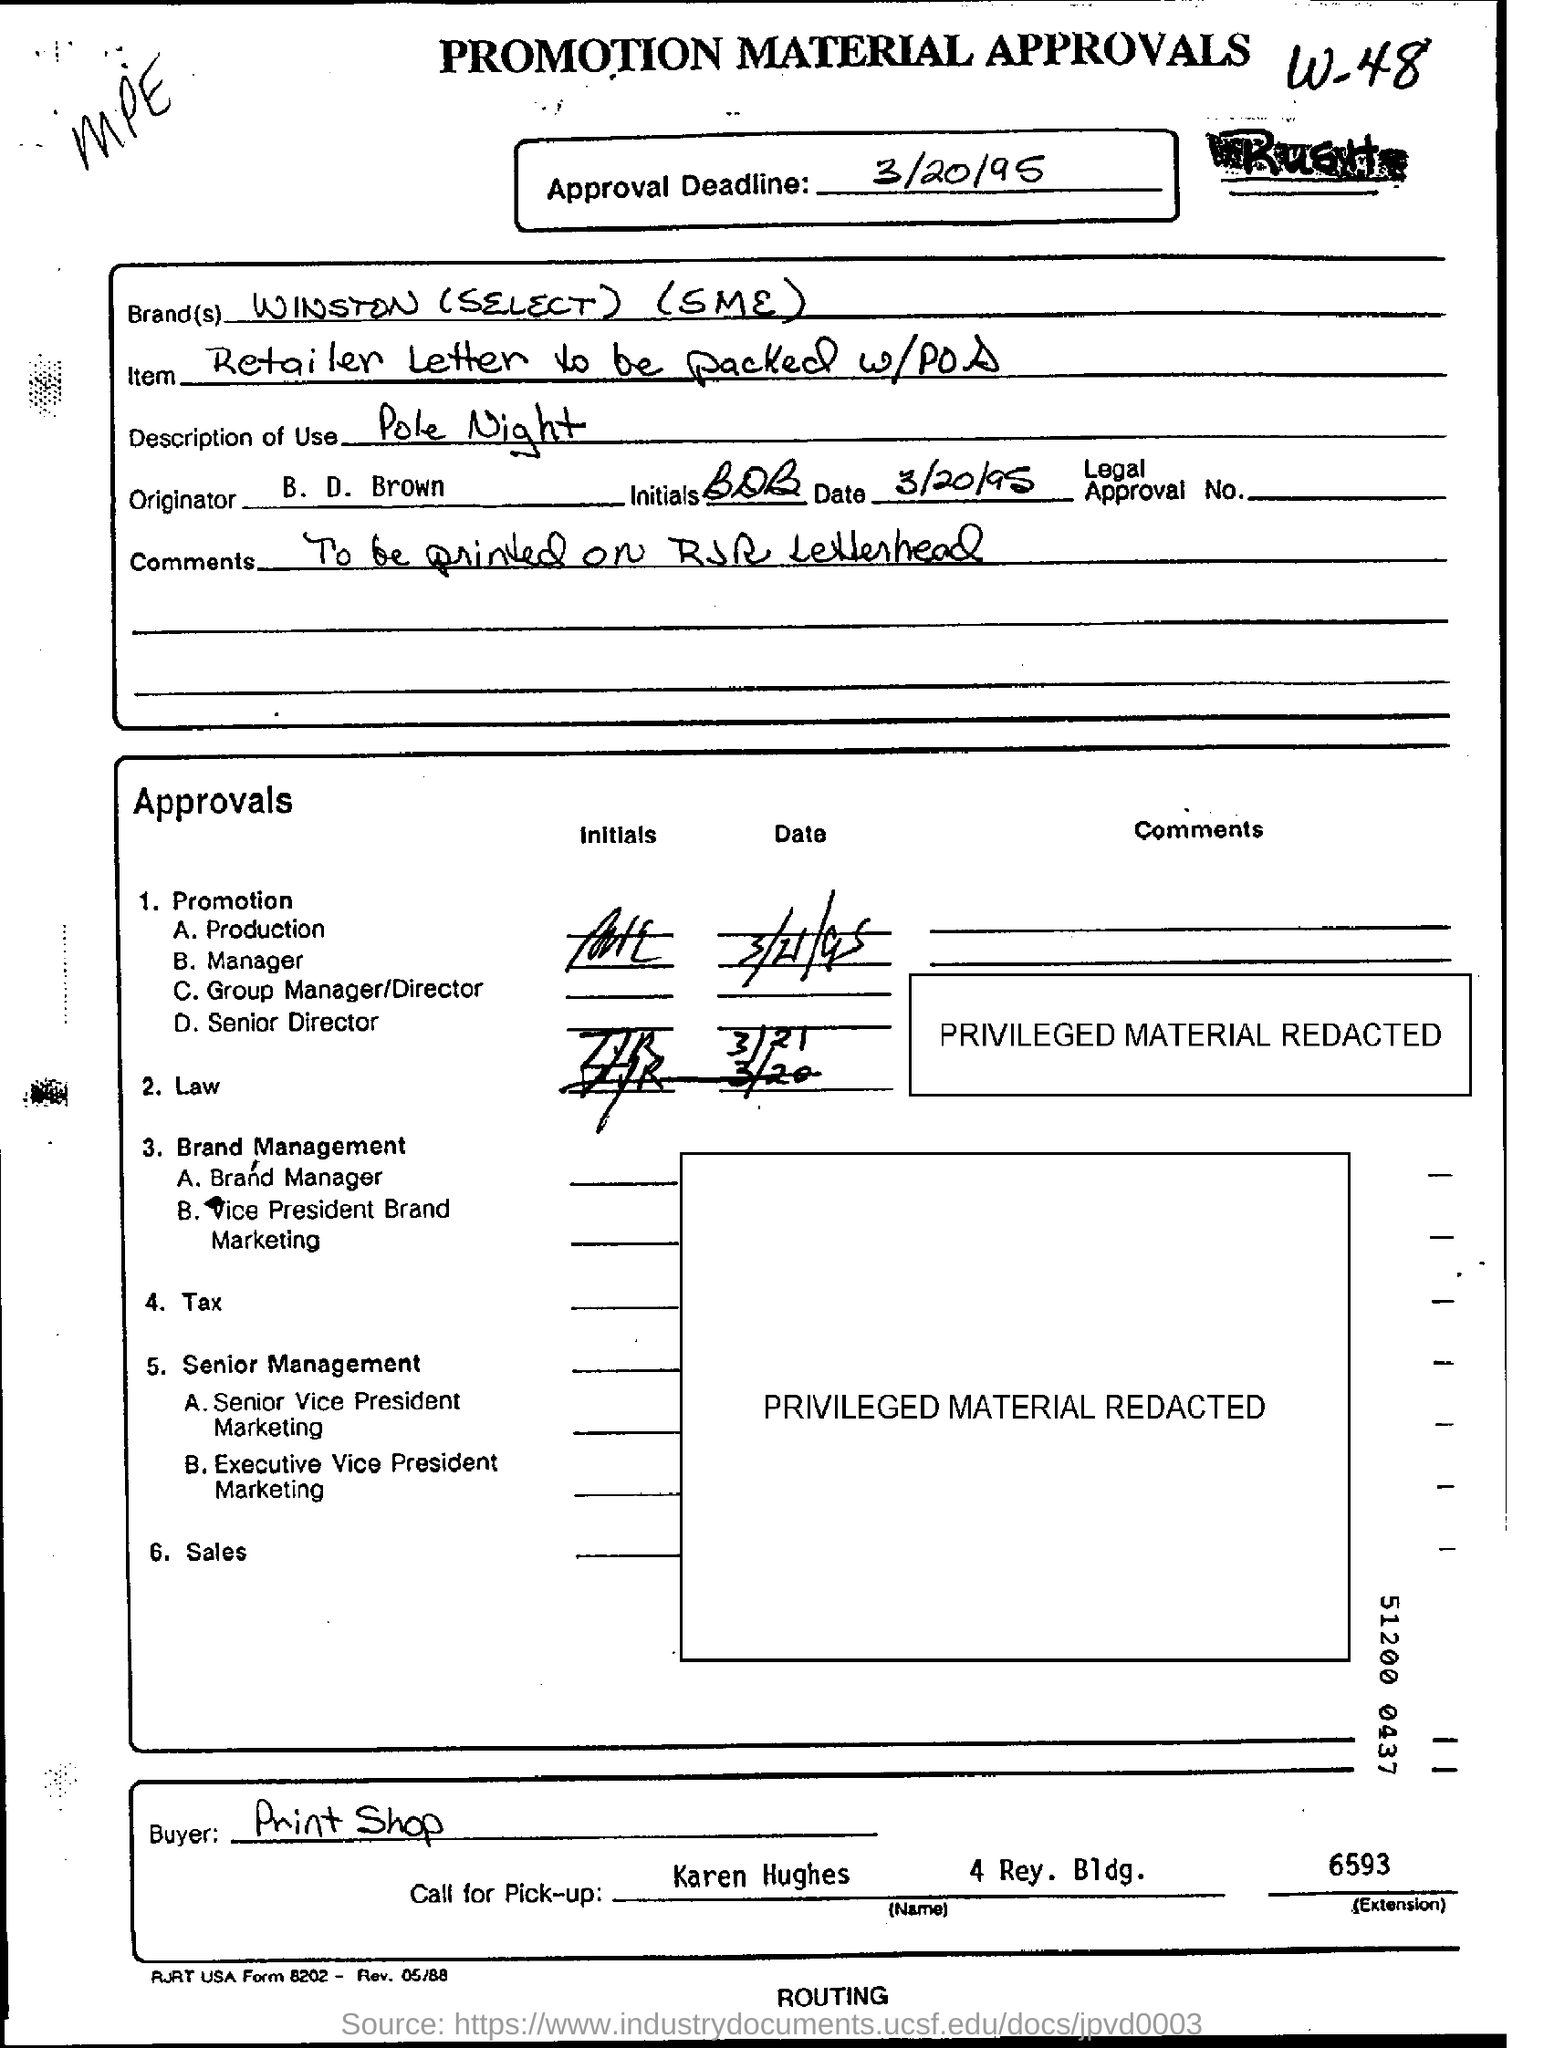What is the brand(s) name?
Provide a succinct answer. WINSTON (SELECT) (SME). What is mentioned in the item ?
Ensure brevity in your answer.  Retailer Letter to be packed w/POS. When is the approval deadline
Your response must be concise. 3/20/95. Who is the originator ?
Keep it short and to the point. B. D. Brown. What is mentioned in the comments ?
Your answer should be compact. To be printed on RJR Letterhead. Who is the buyer ?
Give a very brief answer. Print shop. 